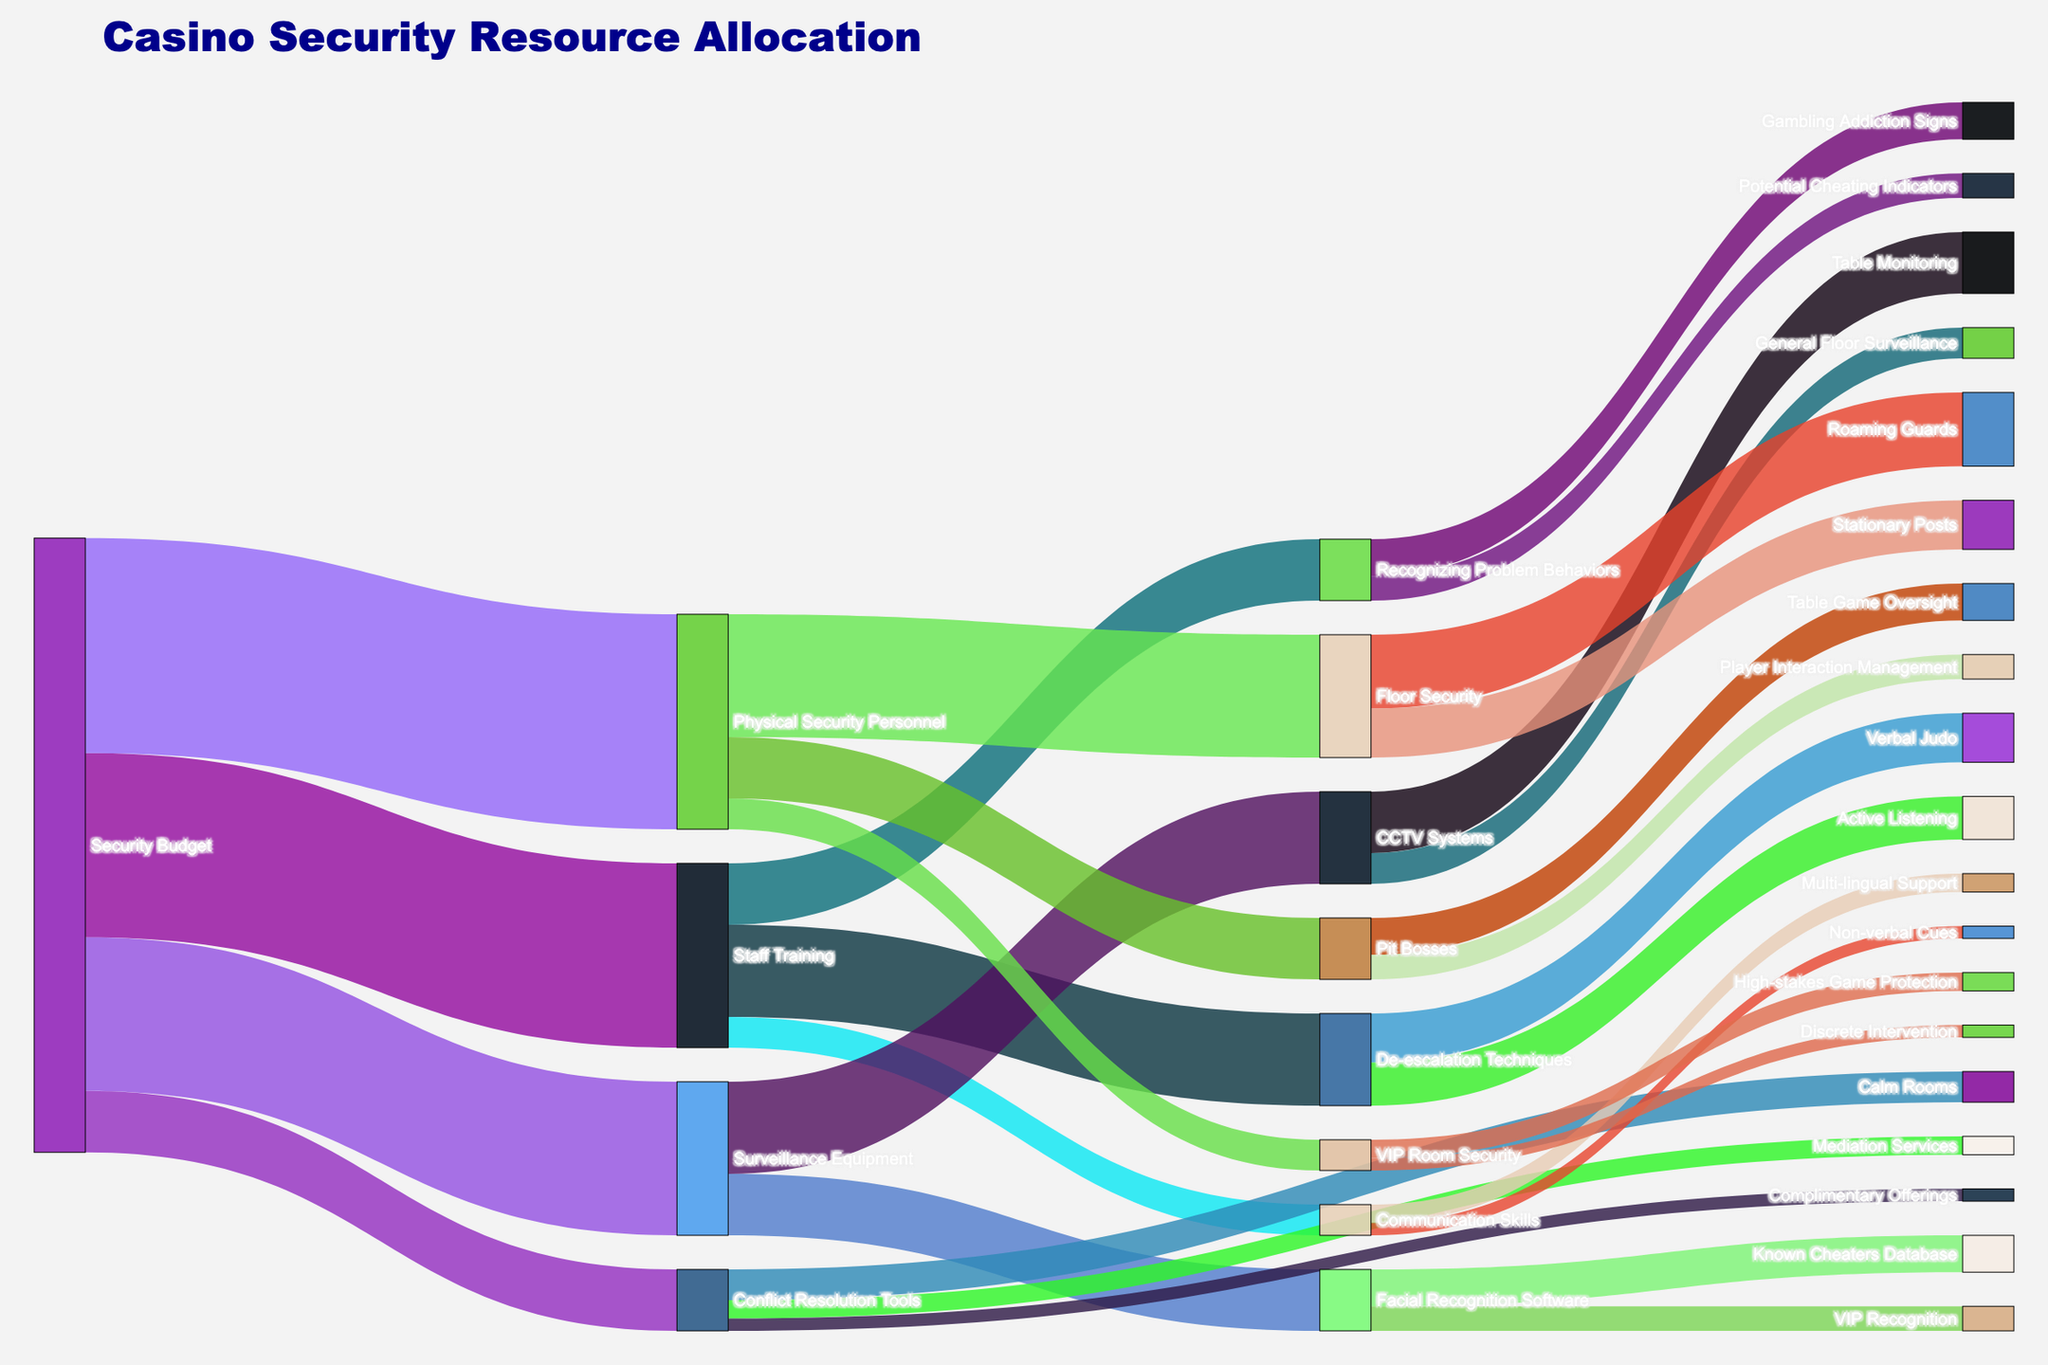who benefits from the most allocation of the security budget? The largest value linked directly to the "Security Budget" is "Physical Security Personnel" with 35 units. Therefore, the Physical Security Personnel receives the most allocation.
Answer: Physical Security Personnel What is the total allocation for Surveillance Equipment? To find the total allocation for Surveillance Equipment, sum the values of its direct targets: CCTV Systems (15) and Facial Recognition Software (10). 15 + 10 = 25
Answer: 25 How much of the security budget is allocated to Staff Training? The direct link from Security Budget to Staff Training shows a value of 30 units.
Answer: 30 Which tool under Conflict Resolution Tools received the least allocation? The direct targets under Conflict Resolution Tools are Calm Rooms, Mediation Services, and Complimentary Offerings. Complimentary Offerings received the least with a value of 2.
Answer: Complimentary Offerings Which has the greater allocation, De-escalation Techniques or Communication Skills? De-escalation Techniques has a total allocation of 15, while Communication Skills has 5. Therefore, De-escalation Techniques has the greater allocation.
Answer: De-escalation Techniques How does the allocation for Roaming Guards compare to Stationary Posts? Roaming Guards receive an allocation of 12, whereas Stationary Posts receive 8. Roaming Guards have a higher allocation.
Answer: Roaming Guards What is the combined allocation for Gambling Addiction Signs and Potential Cheating Indicators under Recognizing Problem Behaviors? Gambling Addiction Signs have a value of 6, and Potential Cheating Indicators have a value of 4. Their combined allocation is 6 + 4 = 10.
Answer: 10 Which conflict resolution tool is allocated more, Mediation Services or Complimentary Offerings? Mediation Services is allocated 3, and Complimentary Offerings is allocated 2. Mediation Services is allocated more.
Answer: Mediation Services How much of the Staff Training allocation is dedicated to De-escalation Techniques? The value linked from Staff Training to De-escalation Techniques is 15 units.
Answer: 15 